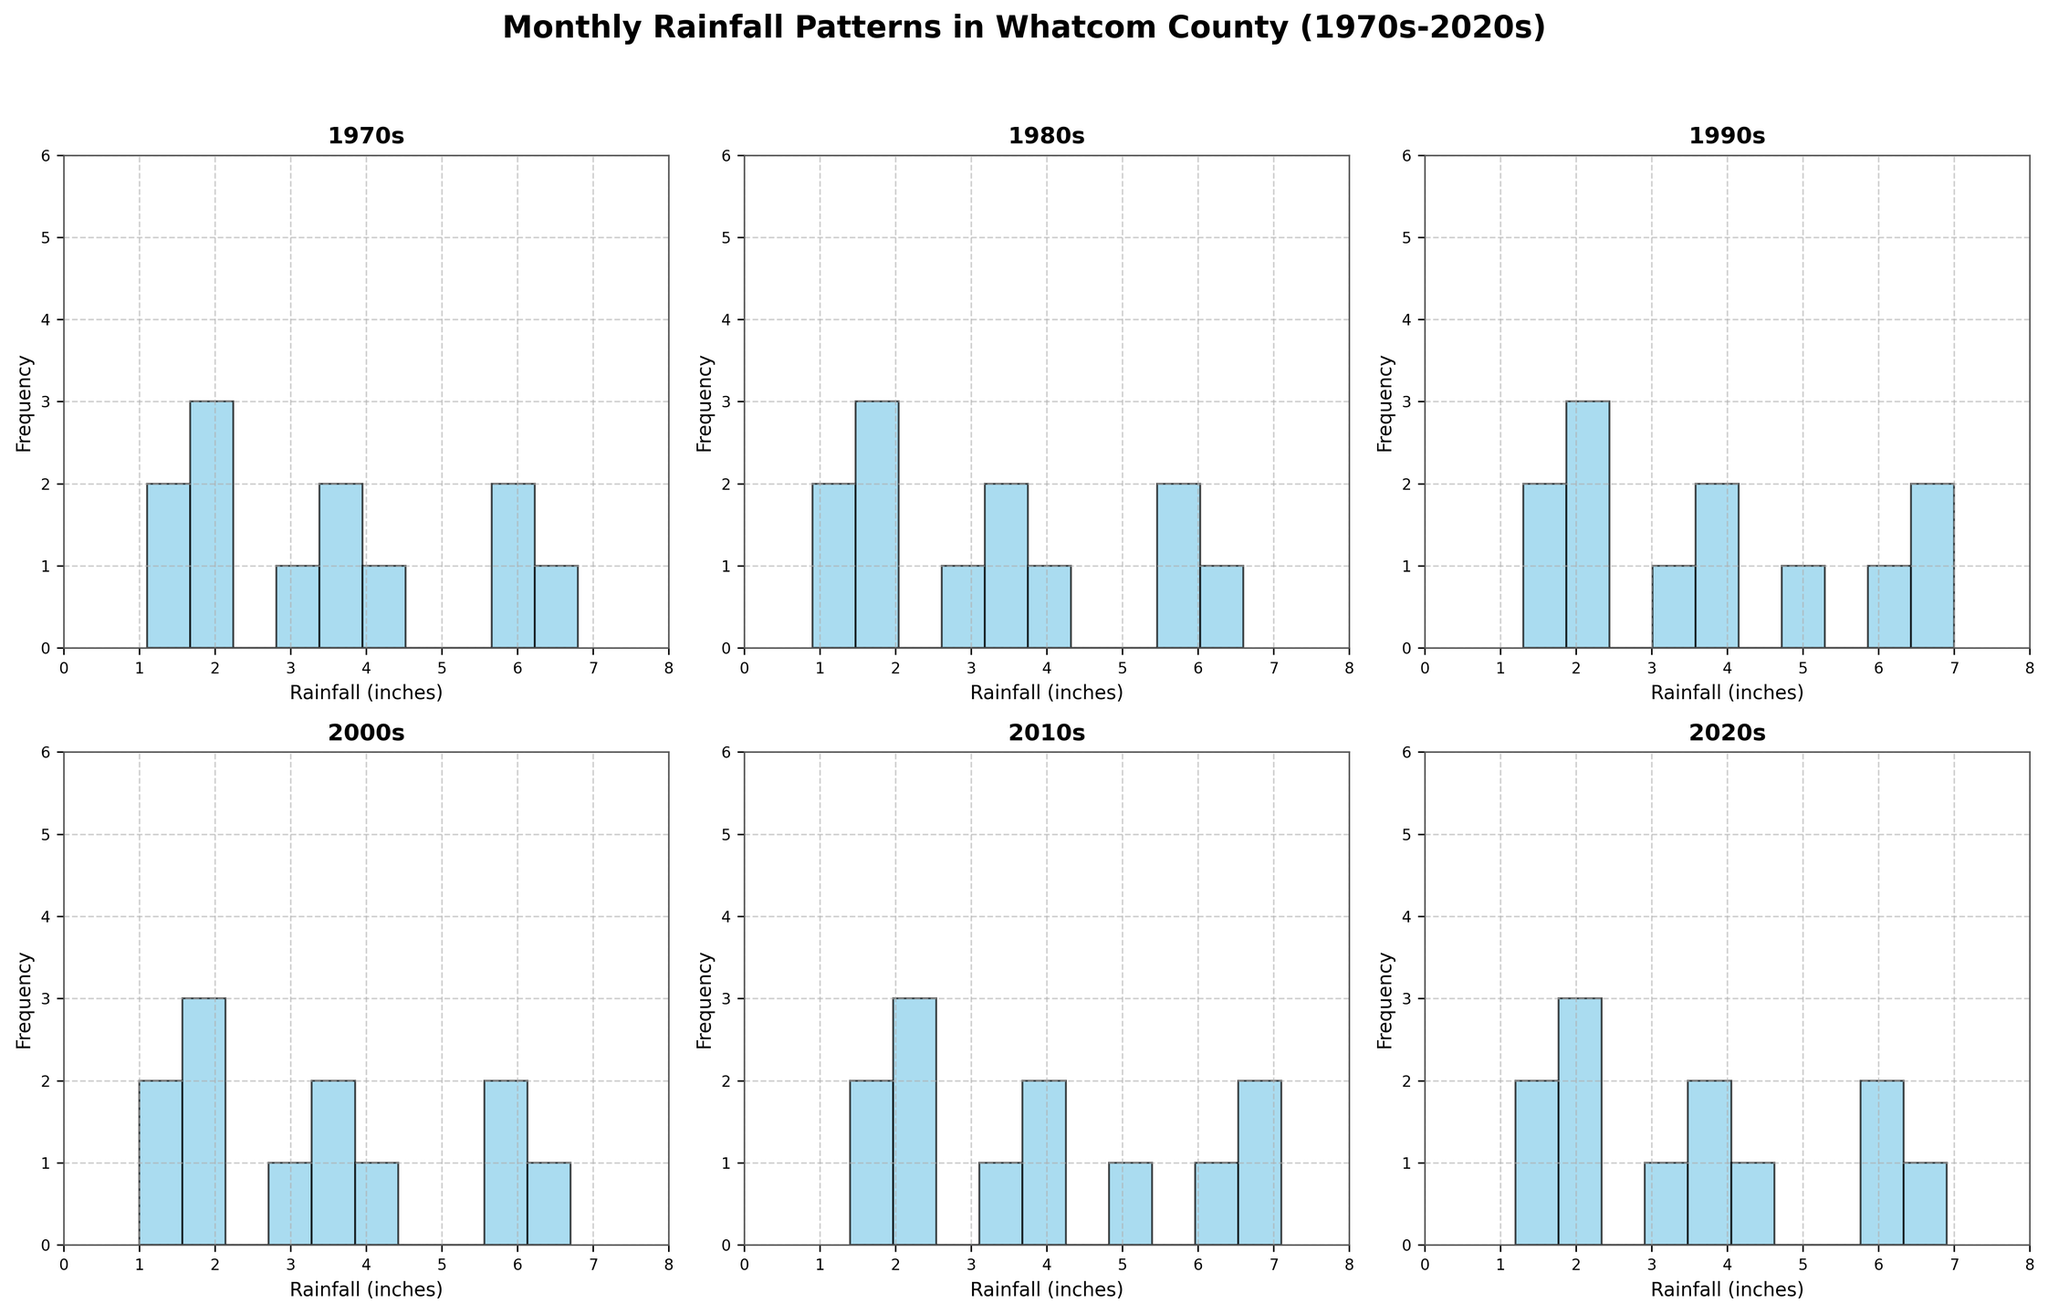What is the title of the figure? The title is located at the top center of the figure, and it summarizes the subject of the entire plot. From the description, the title states the time span and the subject of measurement.
Answer: Monthly Rainfall Patterns in Whatcom County (1970s-2020s) What decade shows the highest frequency of rainfall in the range of 6-8 inches? Each histogram represents a decade and shows the distribution of rainfall amounts. By examining the histograms, you look for the bar that represents 6-8 inches and note its frequency across all decades.
Answer: 1970s Which decade has the lowest average monthly rainfall? To find the lowest average, you would visually check each histogram to see which decade has bars shifted more towards the left (indicating less rainfall). You then compare the central tendencies visually.
Answer: 1970s In which decade is July rainfall the lowest? Look at the bars labeled for July in each decade's subplot. Identify which bar has the lowest height among all the July bars across the decades.
Answer: 1980s How does the distribution of rainfall in January differ between the 1970s and the 2020s? Compare the bars representing January rainfall in the histograms for both the 1970s and the 2020s. Note the differences in their heights and the spread of the bars.
Answer: Higher and less spread out in 2020s Which month shows the most significant increase in average rainfall from the 1970s to the 2020s? By comparing the starting point (1970s) to the endpoint (2020s) for each month in the histogram subplots, we determine which month's rainfall bar has grown the most in height.
Answer: December What's the overall trend in rainfall from 1970s to 2020s in Whatcom County? Look at all the subplots together to identify whether there's a general upward or downward shift in the bars, indicating an increase or decrease in rainfall.
Answer: Increasing Which two decades have the closest average rainfall amounts? Compare the central heights of the histogram bars for each decade and identify the two decades where the bars are most similar.
Answer: 1980s and 2000s What range of rainfall is most common in the 2010s? Observe the histogram for the 2010s and identify which range of bars (e.g., 0-2 inches, 2-4 inches, etc.) is the tallest, indicating the most frequent rainfall range.
Answer: 6-8 inches How do the distributions of rainfall in March in the 1970s and 2010s compare? Look at the bars labeled March in both the 1970s and 2010s subplots. Compare their heights and range to see if one is generally higher or more spread out.
Answer: 2010s are higher and wider 